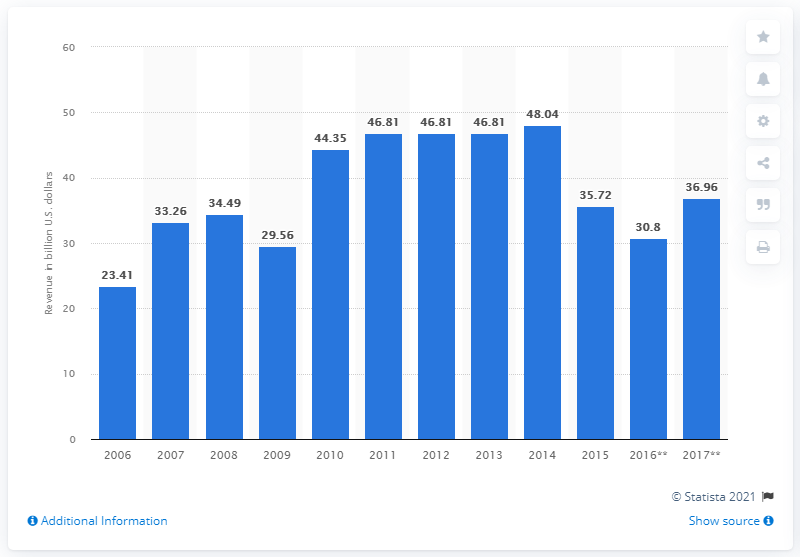Mention a couple of crucial points in this snapshot. In 2017, the market for mechanical engineering in Brazil was valued at approximately 36.96 dollars. 